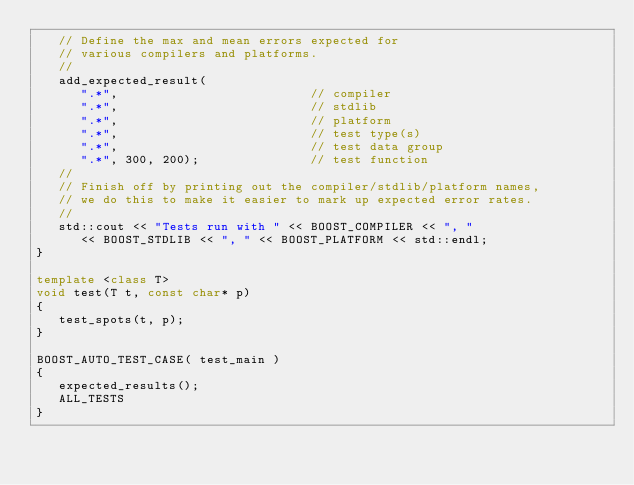<code> <loc_0><loc_0><loc_500><loc_500><_C++_>   // Define the max and mean errors expected for
   // various compilers and platforms.
   //
   add_expected_result(
      ".*",                          // compiler
      ".*",                          // stdlib
      ".*",                          // platform
      ".*",                          // test type(s)
      ".*",                          // test data group
      ".*", 300, 200);               // test function
   //
   // Finish off by printing out the compiler/stdlib/platform names,
   // we do this to make it easier to mark up expected error rates.
   //
   std::cout << "Tests run with " << BOOST_COMPILER << ", "
      << BOOST_STDLIB << ", " << BOOST_PLATFORM << std::endl;
}

template <class T>
void test(T t, const char* p)
{
   test_spots(t, p);
}

BOOST_AUTO_TEST_CASE( test_main )
{
   expected_results();
   ALL_TESTS
}
</code> 